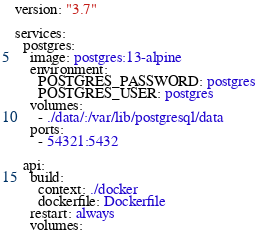<code> <loc_0><loc_0><loc_500><loc_500><_YAML_>version: "3.7"

services:
  postgres:
    image: postgres:13-alpine
    environment:
      POSTGRES_PASSWORD: postgres
      POSTGRES_USER: postgres
    volumes:
      - ./data/:/var/lib/postgresql/data
    ports:
      - 54321:5432

  api:
    build:
      context: ./docker
      dockerfile: Dockerfile
    restart: always
    volumes:</code> 